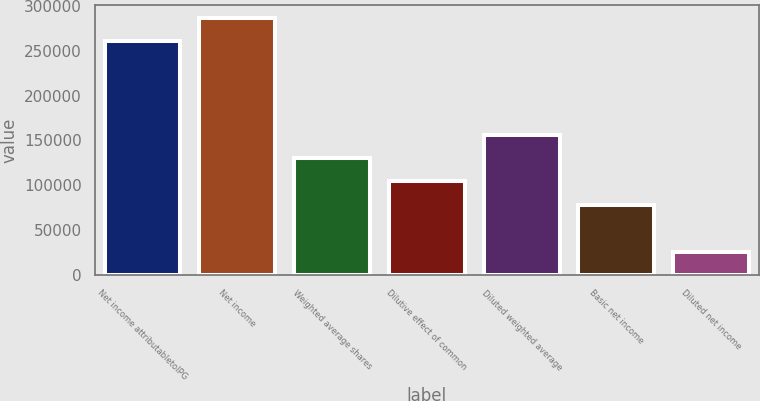Convert chart to OTSL. <chart><loc_0><loc_0><loc_500><loc_500><bar_chart><fcel>Net income attributabletoIPG<fcel>Net income<fcel>Weighted average shares<fcel>Dilutive effect of common<fcel>Diluted weighted average<fcel>Basic net income<fcel>Diluted net income<nl><fcel>260752<fcel>286827<fcel>130378<fcel>104304<fcel>156453<fcel>78229<fcel>26079.6<nl></chart> 